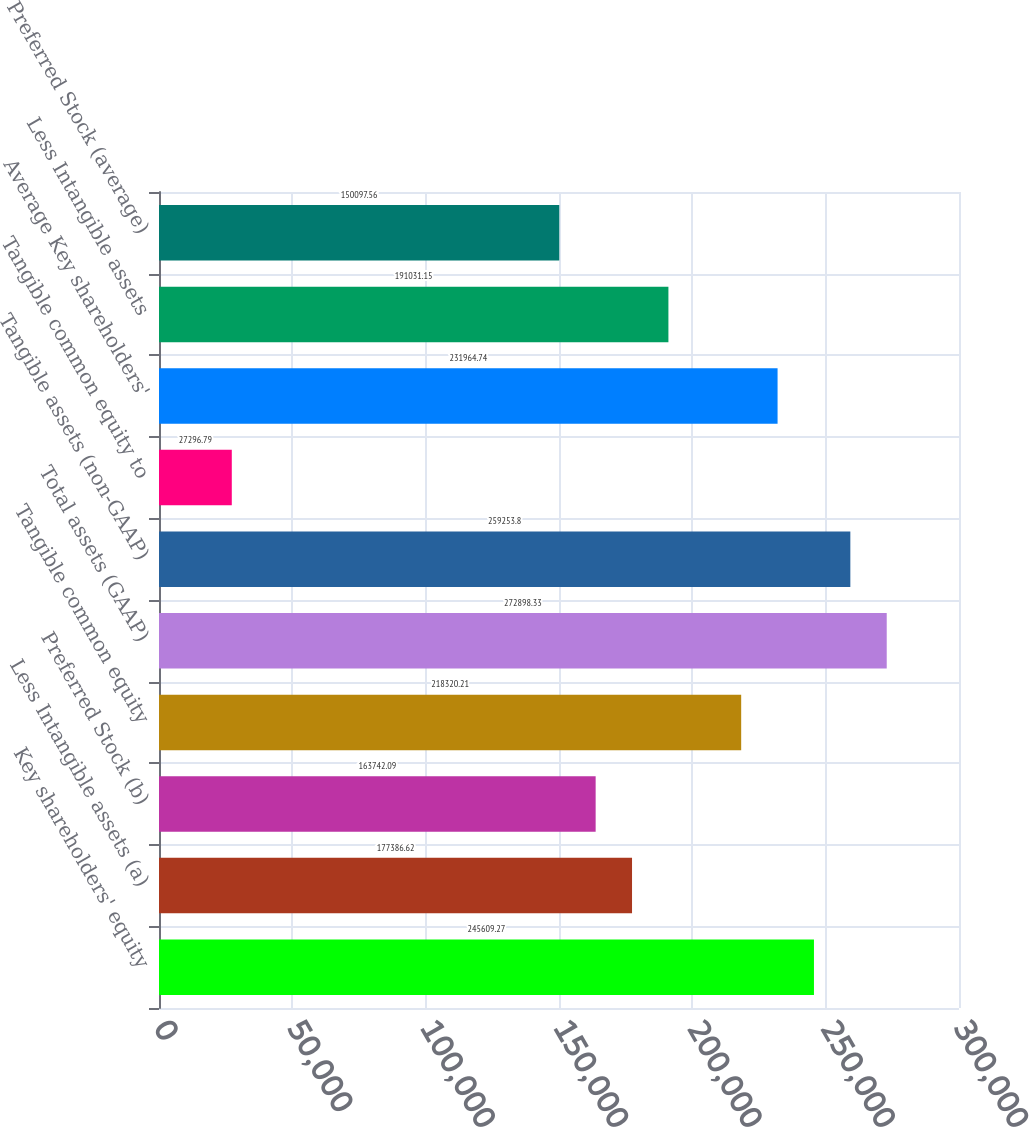<chart> <loc_0><loc_0><loc_500><loc_500><bar_chart><fcel>Key shareholders' equity<fcel>Less Intangible assets (a)<fcel>Preferred Stock (b)<fcel>Tangible common equity<fcel>Total assets (GAAP)<fcel>Tangible assets (non-GAAP)<fcel>Tangible common equity to<fcel>Average Key shareholders'<fcel>Less Intangible assets<fcel>Preferred Stock (average)<nl><fcel>245609<fcel>177387<fcel>163742<fcel>218320<fcel>272898<fcel>259254<fcel>27296.8<fcel>231965<fcel>191031<fcel>150098<nl></chart> 